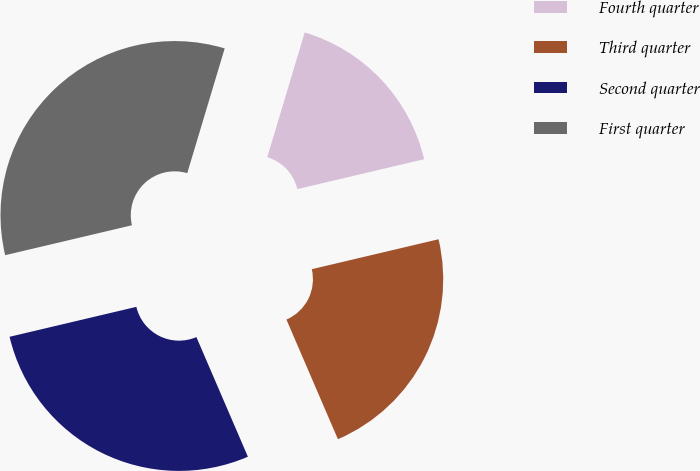<chart> <loc_0><loc_0><loc_500><loc_500><pie_chart><fcel>Fourth quarter<fcel>Third quarter<fcel>Second quarter<fcel>First quarter<nl><fcel>16.67%<fcel>22.22%<fcel>27.78%<fcel>33.33%<nl></chart> 